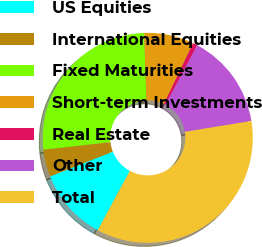Convert chart. <chart><loc_0><loc_0><loc_500><loc_500><pie_chart><fcel>US Equities<fcel>International Equities<fcel>Fixed Maturities<fcel>Short-term Investments<fcel>Real Estate<fcel>Other<fcel>Total<nl><fcel>11.13%<fcel>4.18%<fcel>26.24%<fcel>7.66%<fcel>0.71%<fcel>14.61%<fcel>35.46%<nl></chart> 